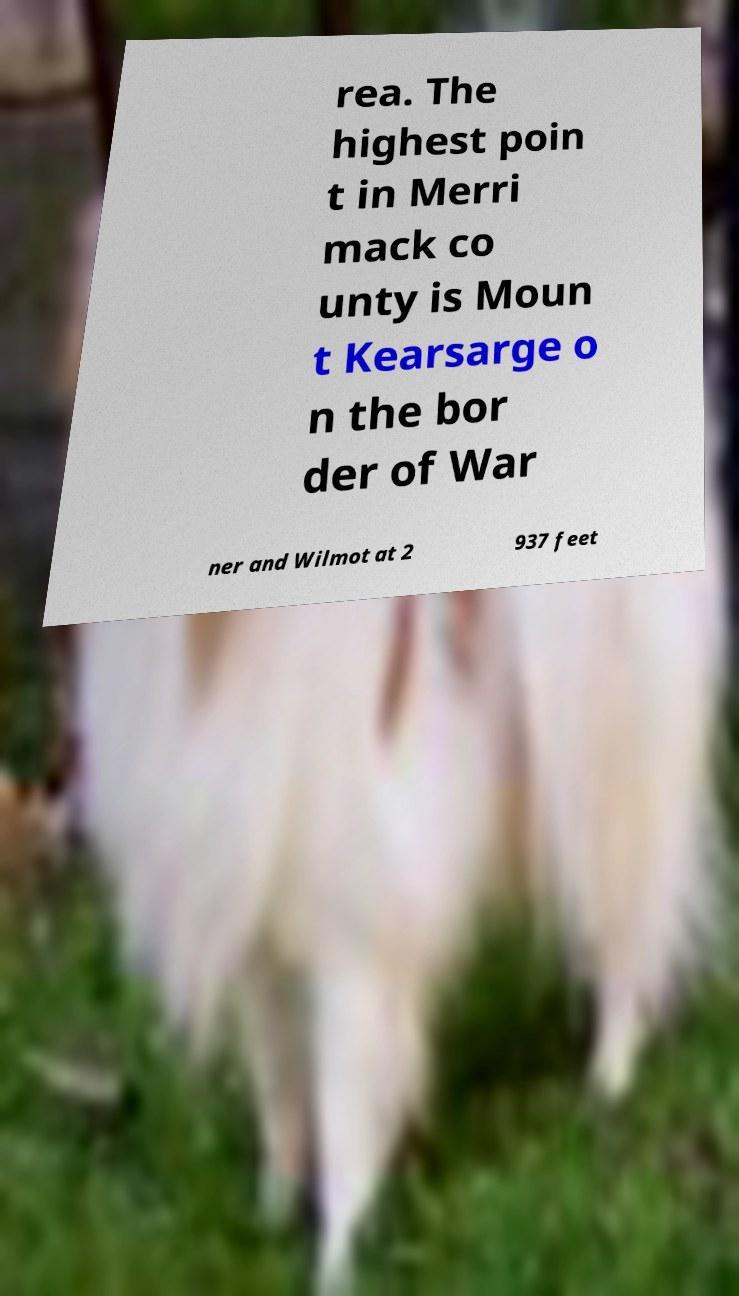Could you assist in decoding the text presented in this image and type it out clearly? rea. The highest poin t in Merri mack co unty is Moun t Kearsarge o n the bor der of War ner and Wilmot at 2 937 feet 